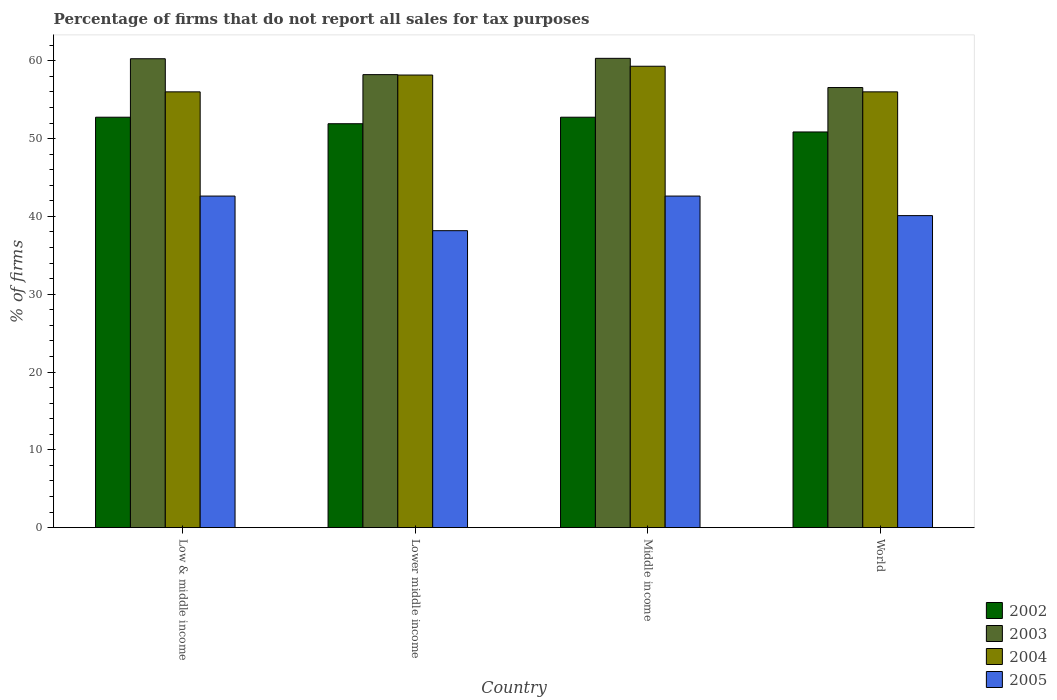How many groups of bars are there?
Make the answer very short. 4. Are the number of bars on each tick of the X-axis equal?
Your answer should be very brief. Yes. How many bars are there on the 3rd tick from the left?
Offer a terse response. 4. In how many cases, is the number of bars for a given country not equal to the number of legend labels?
Keep it short and to the point. 0. What is the percentage of firms that do not report all sales for tax purposes in 2003 in Lower middle income?
Keep it short and to the point. 58.22. Across all countries, what is the maximum percentage of firms that do not report all sales for tax purposes in 2002?
Offer a terse response. 52.75. Across all countries, what is the minimum percentage of firms that do not report all sales for tax purposes in 2004?
Provide a short and direct response. 56.01. In which country was the percentage of firms that do not report all sales for tax purposes in 2004 minimum?
Keep it short and to the point. Low & middle income. What is the total percentage of firms that do not report all sales for tax purposes in 2004 in the graph?
Give a very brief answer. 229.47. What is the difference between the percentage of firms that do not report all sales for tax purposes in 2004 in Low & middle income and that in Lower middle income?
Your answer should be very brief. -2.16. What is the difference between the percentage of firms that do not report all sales for tax purposes in 2004 in Low & middle income and the percentage of firms that do not report all sales for tax purposes in 2005 in Lower middle income?
Offer a terse response. 17.84. What is the average percentage of firms that do not report all sales for tax purposes in 2004 per country?
Ensure brevity in your answer.  57.37. What is the difference between the percentage of firms that do not report all sales for tax purposes of/in 2004 and percentage of firms that do not report all sales for tax purposes of/in 2003 in Middle income?
Give a very brief answer. -1.02. What is the ratio of the percentage of firms that do not report all sales for tax purposes in 2005 in Low & middle income to that in World?
Your answer should be compact. 1.06. Is the percentage of firms that do not report all sales for tax purposes in 2003 in Low & middle income less than that in Lower middle income?
Offer a terse response. No. Is the difference between the percentage of firms that do not report all sales for tax purposes in 2004 in Lower middle income and Middle income greater than the difference between the percentage of firms that do not report all sales for tax purposes in 2003 in Lower middle income and Middle income?
Your answer should be compact. Yes. What is the difference between the highest and the second highest percentage of firms that do not report all sales for tax purposes in 2005?
Give a very brief answer. -2.51. What is the difference between the highest and the lowest percentage of firms that do not report all sales for tax purposes in 2002?
Keep it short and to the point. 1.89. Is the sum of the percentage of firms that do not report all sales for tax purposes in 2003 in Lower middle income and Middle income greater than the maximum percentage of firms that do not report all sales for tax purposes in 2004 across all countries?
Your answer should be compact. Yes. What does the 4th bar from the left in World represents?
Your response must be concise. 2005. Is it the case that in every country, the sum of the percentage of firms that do not report all sales for tax purposes in 2004 and percentage of firms that do not report all sales for tax purposes in 2003 is greater than the percentage of firms that do not report all sales for tax purposes in 2005?
Ensure brevity in your answer.  Yes. Are all the bars in the graph horizontal?
Ensure brevity in your answer.  No. How many countries are there in the graph?
Provide a short and direct response. 4. Are the values on the major ticks of Y-axis written in scientific E-notation?
Make the answer very short. No. Where does the legend appear in the graph?
Offer a terse response. Bottom right. What is the title of the graph?
Provide a succinct answer. Percentage of firms that do not report all sales for tax purposes. What is the label or title of the X-axis?
Keep it short and to the point. Country. What is the label or title of the Y-axis?
Make the answer very short. % of firms. What is the % of firms in 2002 in Low & middle income?
Offer a very short reply. 52.75. What is the % of firms of 2003 in Low & middle income?
Keep it short and to the point. 60.26. What is the % of firms in 2004 in Low & middle income?
Make the answer very short. 56.01. What is the % of firms in 2005 in Low & middle income?
Give a very brief answer. 42.61. What is the % of firms of 2002 in Lower middle income?
Your response must be concise. 51.91. What is the % of firms in 2003 in Lower middle income?
Your answer should be very brief. 58.22. What is the % of firms in 2004 in Lower middle income?
Offer a terse response. 58.16. What is the % of firms in 2005 in Lower middle income?
Your response must be concise. 38.16. What is the % of firms of 2002 in Middle income?
Keep it short and to the point. 52.75. What is the % of firms of 2003 in Middle income?
Ensure brevity in your answer.  60.31. What is the % of firms in 2004 in Middle income?
Offer a terse response. 59.3. What is the % of firms in 2005 in Middle income?
Provide a short and direct response. 42.61. What is the % of firms of 2002 in World?
Give a very brief answer. 50.85. What is the % of firms in 2003 in World?
Your response must be concise. 56.56. What is the % of firms of 2004 in World?
Provide a succinct answer. 56.01. What is the % of firms in 2005 in World?
Ensure brevity in your answer.  40.1. Across all countries, what is the maximum % of firms in 2002?
Provide a succinct answer. 52.75. Across all countries, what is the maximum % of firms of 2003?
Offer a terse response. 60.31. Across all countries, what is the maximum % of firms in 2004?
Your answer should be compact. 59.3. Across all countries, what is the maximum % of firms of 2005?
Give a very brief answer. 42.61. Across all countries, what is the minimum % of firms in 2002?
Your response must be concise. 50.85. Across all countries, what is the minimum % of firms in 2003?
Offer a very short reply. 56.56. Across all countries, what is the minimum % of firms in 2004?
Your answer should be compact. 56.01. Across all countries, what is the minimum % of firms of 2005?
Offer a very short reply. 38.16. What is the total % of firms in 2002 in the graph?
Offer a very short reply. 208.25. What is the total % of firms of 2003 in the graph?
Offer a terse response. 235.35. What is the total % of firms in 2004 in the graph?
Offer a very short reply. 229.47. What is the total % of firms in 2005 in the graph?
Provide a succinct answer. 163.48. What is the difference between the % of firms in 2002 in Low & middle income and that in Lower middle income?
Offer a terse response. 0.84. What is the difference between the % of firms of 2003 in Low & middle income and that in Lower middle income?
Ensure brevity in your answer.  2.04. What is the difference between the % of firms in 2004 in Low & middle income and that in Lower middle income?
Offer a terse response. -2.16. What is the difference between the % of firms of 2005 in Low & middle income and that in Lower middle income?
Provide a short and direct response. 4.45. What is the difference between the % of firms in 2003 in Low & middle income and that in Middle income?
Provide a succinct answer. -0.05. What is the difference between the % of firms in 2004 in Low & middle income and that in Middle income?
Keep it short and to the point. -3.29. What is the difference between the % of firms in 2002 in Low & middle income and that in World?
Make the answer very short. 1.89. What is the difference between the % of firms of 2003 in Low & middle income and that in World?
Ensure brevity in your answer.  3.7. What is the difference between the % of firms of 2005 in Low & middle income and that in World?
Your answer should be compact. 2.51. What is the difference between the % of firms of 2002 in Lower middle income and that in Middle income?
Provide a short and direct response. -0.84. What is the difference between the % of firms of 2003 in Lower middle income and that in Middle income?
Keep it short and to the point. -2.09. What is the difference between the % of firms of 2004 in Lower middle income and that in Middle income?
Give a very brief answer. -1.13. What is the difference between the % of firms in 2005 in Lower middle income and that in Middle income?
Make the answer very short. -4.45. What is the difference between the % of firms of 2002 in Lower middle income and that in World?
Offer a very short reply. 1.06. What is the difference between the % of firms of 2003 in Lower middle income and that in World?
Your answer should be compact. 1.66. What is the difference between the % of firms of 2004 in Lower middle income and that in World?
Your answer should be very brief. 2.16. What is the difference between the % of firms of 2005 in Lower middle income and that in World?
Offer a very short reply. -1.94. What is the difference between the % of firms of 2002 in Middle income and that in World?
Your response must be concise. 1.89. What is the difference between the % of firms in 2003 in Middle income and that in World?
Provide a short and direct response. 3.75. What is the difference between the % of firms in 2004 in Middle income and that in World?
Ensure brevity in your answer.  3.29. What is the difference between the % of firms of 2005 in Middle income and that in World?
Give a very brief answer. 2.51. What is the difference between the % of firms in 2002 in Low & middle income and the % of firms in 2003 in Lower middle income?
Ensure brevity in your answer.  -5.47. What is the difference between the % of firms in 2002 in Low & middle income and the % of firms in 2004 in Lower middle income?
Keep it short and to the point. -5.42. What is the difference between the % of firms of 2002 in Low & middle income and the % of firms of 2005 in Lower middle income?
Make the answer very short. 14.58. What is the difference between the % of firms of 2003 in Low & middle income and the % of firms of 2004 in Lower middle income?
Make the answer very short. 2.1. What is the difference between the % of firms in 2003 in Low & middle income and the % of firms in 2005 in Lower middle income?
Provide a succinct answer. 22.1. What is the difference between the % of firms in 2004 in Low & middle income and the % of firms in 2005 in Lower middle income?
Provide a short and direct response. 17.84. What is the difference between the % of firms in 2002 in Low & middle income and the % of firms in 2003 in Middle income?
Ensure brevity in your answer.  -7.57. What is the difference between the % of firms in 2002 in Low & middle income and the % of firms in 2004 in Middle income?
Your answer should be compact. -6.55. What is the difference between the % of firms of 2002 in Low & middle income and the % of firms of 2005 in Middle income?
Your response must be concise. 10.13. What is the difference between the % of firms of 2003 in Low & middle income and the % of firms of 2004 in Middle income?
Offer a terse response. 0.96. What is the difference between the % of firms in 2003 in Low & middle income and the % of firms in 2005 in Middle income?
Ensure brevity in your answer.  17.65. What is the difference between the % of firms of 2004 in Low & middle income and the % of firms of 2005 in Middle income?
Ensure brevity in your answer.  13.39. What is the difference between the % of firms of 2002 in Low & middle income and the % of firms of 2003 in World?
Provide a succinct answer. -3.81. What is the difference between the % of firms in 2002 in Low & middle income and the % of firms in 2004 in World?
Your answer should be very brief. -3.26. What is the difference between the % of firms in 2002 in Low & middle income and the % of firms in 2005 in World?
Provide a short and direct response. 12.65. What is the difference between the % of firms in 2003 in Low & middle income and the % of firms in 2004 in World?
Give a very brief answer. 4.25. What is the difference between the % of firms in 2003 in Low & middle income and the % of firms in 2005 in World?
Your response must be concise. 20.16. What is the difference between the % of firms in 2004 in Low & middle income and the % of firms in 2005 in World?
Give a very brief answer. 15.91. What is the difference between the % of firms of 2002 in Lower middle income and the % of firms of 2003 in Middle income?
Keep it short and to the point. -8.4. What is the difference between the % of firms of 2002 in Lower middle income and the % of firms of 2004 in Middle income?
Your answer should be very brief. -7.39. What is the difference between the % of firms of 2002 in Lower middle income and the % of firms of 2005 in Middle income?
Offer a very short reply. 9.3. What is the difference between the % of firms of 2003 in Lower middle income and the % of firms of 2004 in Middle income?
Give a very brief answer. -1.08. What is the difference between the % of firms in 2003 in Lower middle income and the % of firms in 2005 in Middle income?
Provide a succinct answer. 15.61. What is the difference between the % of firms in 2004 in Lower middle income and the % of firms in 2005 in Middle income?
Offer a terse response. 15.55. What is the difference between the % of firms in 2002 in Lower middle income and the % of firms in 2003 in World?
Keep it short and to the point. -4.65. What is the difference between the % of firms of 2002 in Lower middle income and the % of firms of 2004 in World?
Give a very brief answer. -4.1. What is the difference between the % of firms of 2002 in Lower middle income and the % of firms of 2005 in World?
Offer a very short reply. 11.81. What is the difference between the % of firms of 2003 in Lower middle income and the % of firms of 2004 in World?
Give a very brief answer. 2.21. What is the difference between the % of firms of 2003 in Lower middle income and the % of firms of 2005 in World?
Keep it short and to the point. 18.12. What is the difference between the % of firms of 2004 in Lower middle income and the % of firms of 2005 in World?
Keep it short and to the point. 18.07. What is the difference between the % of firms of 2002 in Middle income and the % of firms of 2003 in World?
Provide a succinct answer. -3.81. What is the difference between the % of firms of 2002 in Middle income and the % of firms of 2004 in World?
Give a very brief answer. -3.26. What is the difference between the % of firms of 2002 in Middle income and the % of firms of 2005 in World?
Provide a succinct answer. 12.65. What is the difference between the % of firms in 2003 in Middle income and the % of firms in 2004 in World?
Make the answer very short. 4.31. What is the difference between the % of firms in 2003 in Middle income and the % of firms in 2005 in World?
Your answer should be very brief. 20.21. What is the difference between the % of firms of 2004 in Middle income and the % of firms of 2005 in World?
Your answer should be compact. 19.2. What is the average % of firms in 2002 per country?
Provide a succinct answer. 52.06. What is the average % of firms in 2003 per country?
Provide a short and direct response. 58.84. What is the average % of firms in 2004 per country?
Your answer should be very brief. 57.37. What is the average % of firms of 2005 per country?
Your answer should be very brief. 40.87. What is the difference between the % of firms of 2002 and % of firms of 2003 in Low & middle income?
Ensure brevity in your answer.  -7.51. What is the difference between the % of firms in 2002 and % of firms in 2004 in Low & middle income?
Provide a succinct answer. -3.26. What is the difference between the % of firms of 2002 and % of firms of 2005 in Low & middle income?
Keep it short and to the point. 10.13. What is the difference between the % of firms in 2003 and % of firms in 2004 in Low & middle income?
Keep it short and to the point. 4.25. What is the difference between the % of firms in 2003 and % of firms in 2005 in Low & middle income?
Keep it short and to the point. 17.65. What is the difference between the % of firms in 2004 and % of firms in 2005 in Low & middle income?
Your answer should be very brief. 13.39. What is the difference between the % of firms of 2002 and % of firms of 2003 in Lower middle income?
Provide a short and direct response. -6.31. What is the difference between the % of firms of 2002 and % of firms of 2004 in Lower middle income?
Provide a short and direct response. -6.26. What is the difference between the % of firms in 2002 and % of firms in 2005 in Lower middle income?
Your answer should be compact. 13.75. What is the difference between the % of firms of 2003 and % of firms of 2004 in Lower middle income?
Give a very brief answer. 0.05. What is the difference between the % of firms in 2003 and % of firms in 2005 in Lower middle income?
Offer a terse response. 20.06. What is the difference between the % of firms in 2004 and % of firms in 2005 in Lower middle income?
Keep it short and to the point. 20. What is the difference between the % of firms of 2002 and % of firms of 2003 in Middle income?
Offer a very short reply. -7.57. What is the difference between the % of firms in 2002 and % of firms in 2004 in Middle income?
Your answer should be compact. -6.55. What is the difference between the % of firms in 2002 and % of firms in 2005 in Middle income?
Make the answer very short. 10.13. What is the difference between the % of firms of 2003 and % of firms of 2004 in Middle income?
Provide a short and direct response. 1.02. What is the difference between the % of firms in 2003 and % of firms in 2005 in Middle income?
Give a very brief answer. 17.7. What is the difference between the % of firms in 2004 and % of firms in 2005 in Middle income?
Provide a succinct answer. 16.69. What is the difference between the % of firms of 2002 and % of firms of 2003 in World?
Ensure brevity in your answer.  -5.71. What is the difference between the % of firms of 2002 and % of firms of 2004 in World?
Your answer should be very brief. -5.15. What is the difference between the % of firms of 2002 and % of firms of 2005 in World?
Ensure brevity in your answer.  10.75. What is the difference between the % of firms in 2003 and % of firms in 2004 in World?
Offer a very short reply. 0.56. What is the difference between the % of firms of 2003 and % of firms of 2005 in World?
Offer a very short reply. 16.46. What is the difference between the % of firms of 2004 and % of firms of 2005 in World?
Provide a succinct answer. 15.91. What is the ratio of the % of firms in 2002 in Low & middle income to that in Lower middle income?
Your answer should be compact. 1.02. What is the ratio of the % of firms of 2003 in Low & middle income to that in Lower middle income?
Your answer should be very brief. 1.04. What is the ratio of the % of firms in 2004 in Low & middle income to that in Lower middle income?
Offer a terse response. 0.96. What is the ratio of the % of firms of 2005 in Low & middle income to that in Lower middle income?
Give a very brief answer. 1.12. What is the ratio of the % of firms in 2002 in Low & middle income to that in Middle income?
Your answer should be very brief. 1. What is the ratio of the % of firms of 2004 in Low & middle income to that in Middle income?
Make the answer very short. 0.94. What is the ratio of the % of firms in 2002 in Low & middle income to that in World?
Make the answer very short. 1.04. What is the ratio of the % of firms in 2003 in Low & middle income to that in World?
Your answer should be compact. 1.07. What is the ratio of the % of firms of 2004 in Low & middle income to that in World?
Give a very brief answer. 1. What is the ratio of the % of firms in 2005 in Low & middle income to that in World?
Your answer should be very brief. 1.06. What is the ratio of the % of firms in 2002 in Lower middle income to that in Middle income?
Your answer should be very brief. 0.98. What is the ratio of the % of firms in 2003 in Lower middle income to that in Middle income?
Provide a succinct answer. 0.97. What is the ratio of the % of firms in 2004 in Lower middle income to that in Middle income?
Your response must be concise. 0.98. What is the ratio of the % of firms in 2005 in Lower middle income to that in Middle income?
Keep it short and to the point. 0.9. What is the ratio of the % of firms of 2002 in Lower middle income to that in World?
Offer a terse response. 1.02. What is the ratio of the % of firms in 2003 in Lower middle income to that in World?
Provide a succinct answer. 1.03. What is the ratio of the % of firms of 2004 in Lower middle income to that in World?
Provide a short and direct response. 1.04. What is the ratio of the % of firms of 2005 in Lower middle income to that in World?
Offer a very short reply. 0.95. What is the ratio of the % of firms in 2002 in Middle income to that in World?
Offer a terse response. 1.04. What is the ratio of the % of firms in 2003 in Middle income to that in World?
Your answer should be very brief. 1.07. What is the ratio of the % of firms of 2004 in Middle income to that in World?
Your response must be concise. 1.06. What is the ratio of the % of firms of 2005 in Middle income to that in World?
Your answer should be compact. 1.06. What is the difference between the highest and the second highest % of firms of 2002?
Offer a very short reply. 0. What is the difference between the highest and the second highest % of firms of 2003?
Offer a terse response. 0.05. What is the difference between the highest and the second highest % of firms in 2004?
Your answer should be compact. 1.13. What is the difference between the highest and the lowest % of firms of 2002?
Your answer should be very brief. 1.89. What is the difference between the highest and the lowest % of firms in 2003?
Provide a succinct answer. 3.75. What is the difference between the highest and the lowest % of firms in 2004?
Provide a succinct answer. 3.29. What is the difference between the highest and the lowest % of firms in 2005?
Offer a terse response. 4.45. 